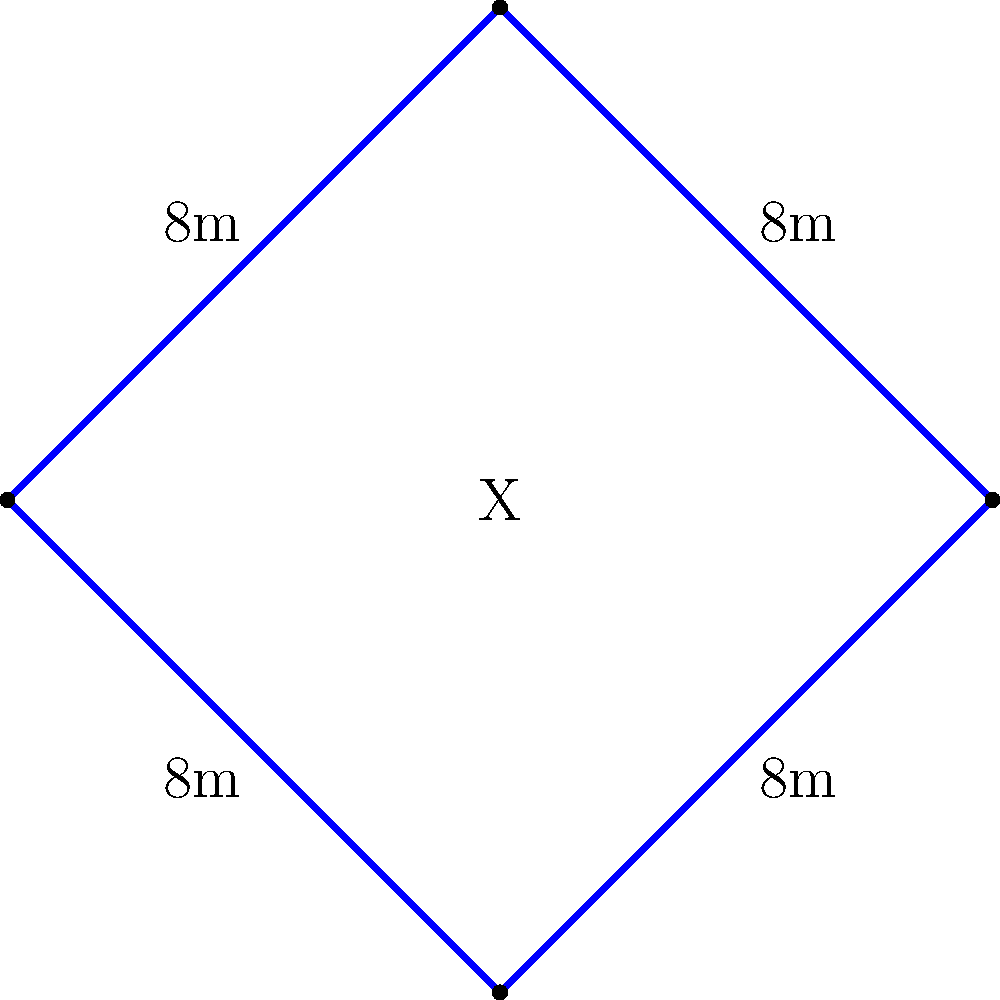In "The Afterparty", Xavier's pool is shaped like a stylized 'X'. Each arm of the 'X' is 8 meters long. What is the perimeter of Xavier's pool? To find the perimeter of Xavier's X-shaped pool, we need to follow these steps:

1) First, we need to understand that the perimeter is the total distance around the edge of the shape.

2) The pool is shaped like an 'X', which consists of four equal arms.

3) We are given that each arm of the 'X' is 8 meters long.

4) To calculate the perimeter, we need to add up the lengths of all four arms:

   $$ \text{Perimeter} = 8\text{ m} + 8\text{ m} + 8\text{ m} + 8\text{ m} $$

5) This can be simplified to:

   $$ \text{Perimeter} = 4 \times 8\text{ m} = 32\text{ m} $$

Therefore, the perimeter of Xavier's pool is 32 meters.
Answer: 32 meters 